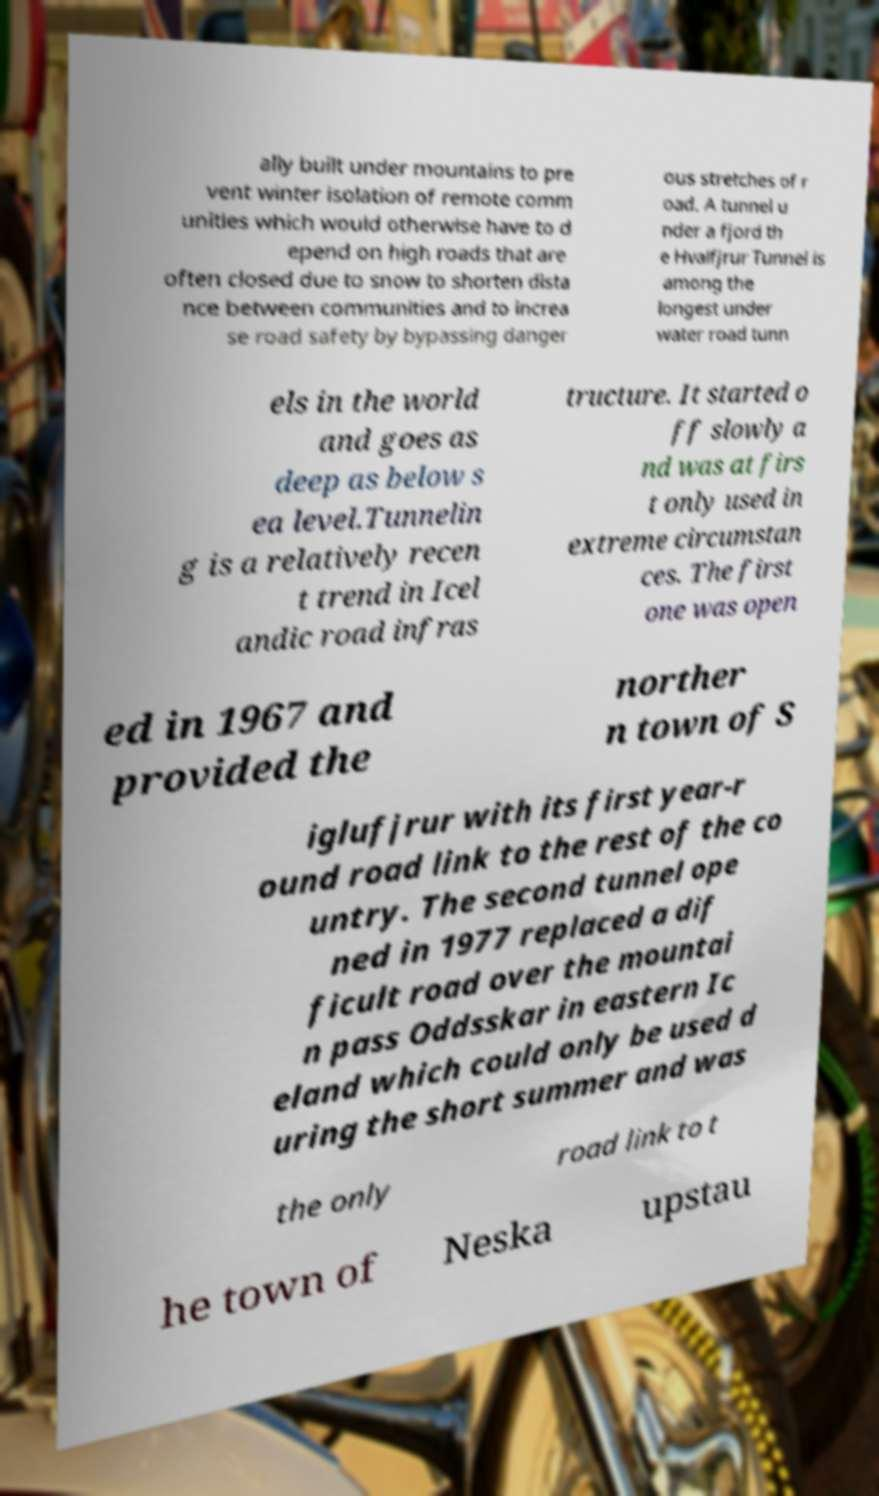Could you extract and type out the text from this image? ally built under mountains to pre vent winter isolation of remote comm unities which would otherwise have to d epend on high roads that are often closed due to snow to shorten dista nce between communities and to increa se road safety by bypassing danger ous stretches of r oad. A tunnel u nder a fjord th e Hvalfjrur Tunnel is among the longest under water road tunn els in the world and goes as deep as below s ea level.Tunnelin g is a relatively recen t trend in Icel andic road infras tructure. It started o ff slowly a nd was at firs t only used in extreme circumstan ces. The first one was open ed in 1967 and provided the norther n town of S iglufjrur with its first year-r ound road link to the rest of the co untry. The second tunnel ope ned in 1977 replaced a dif ficult road over the mountai n pass Oddsskar in eastern Ic eland which could only be used d uring the short summer and was the only road link to t he town of Neska upstau 